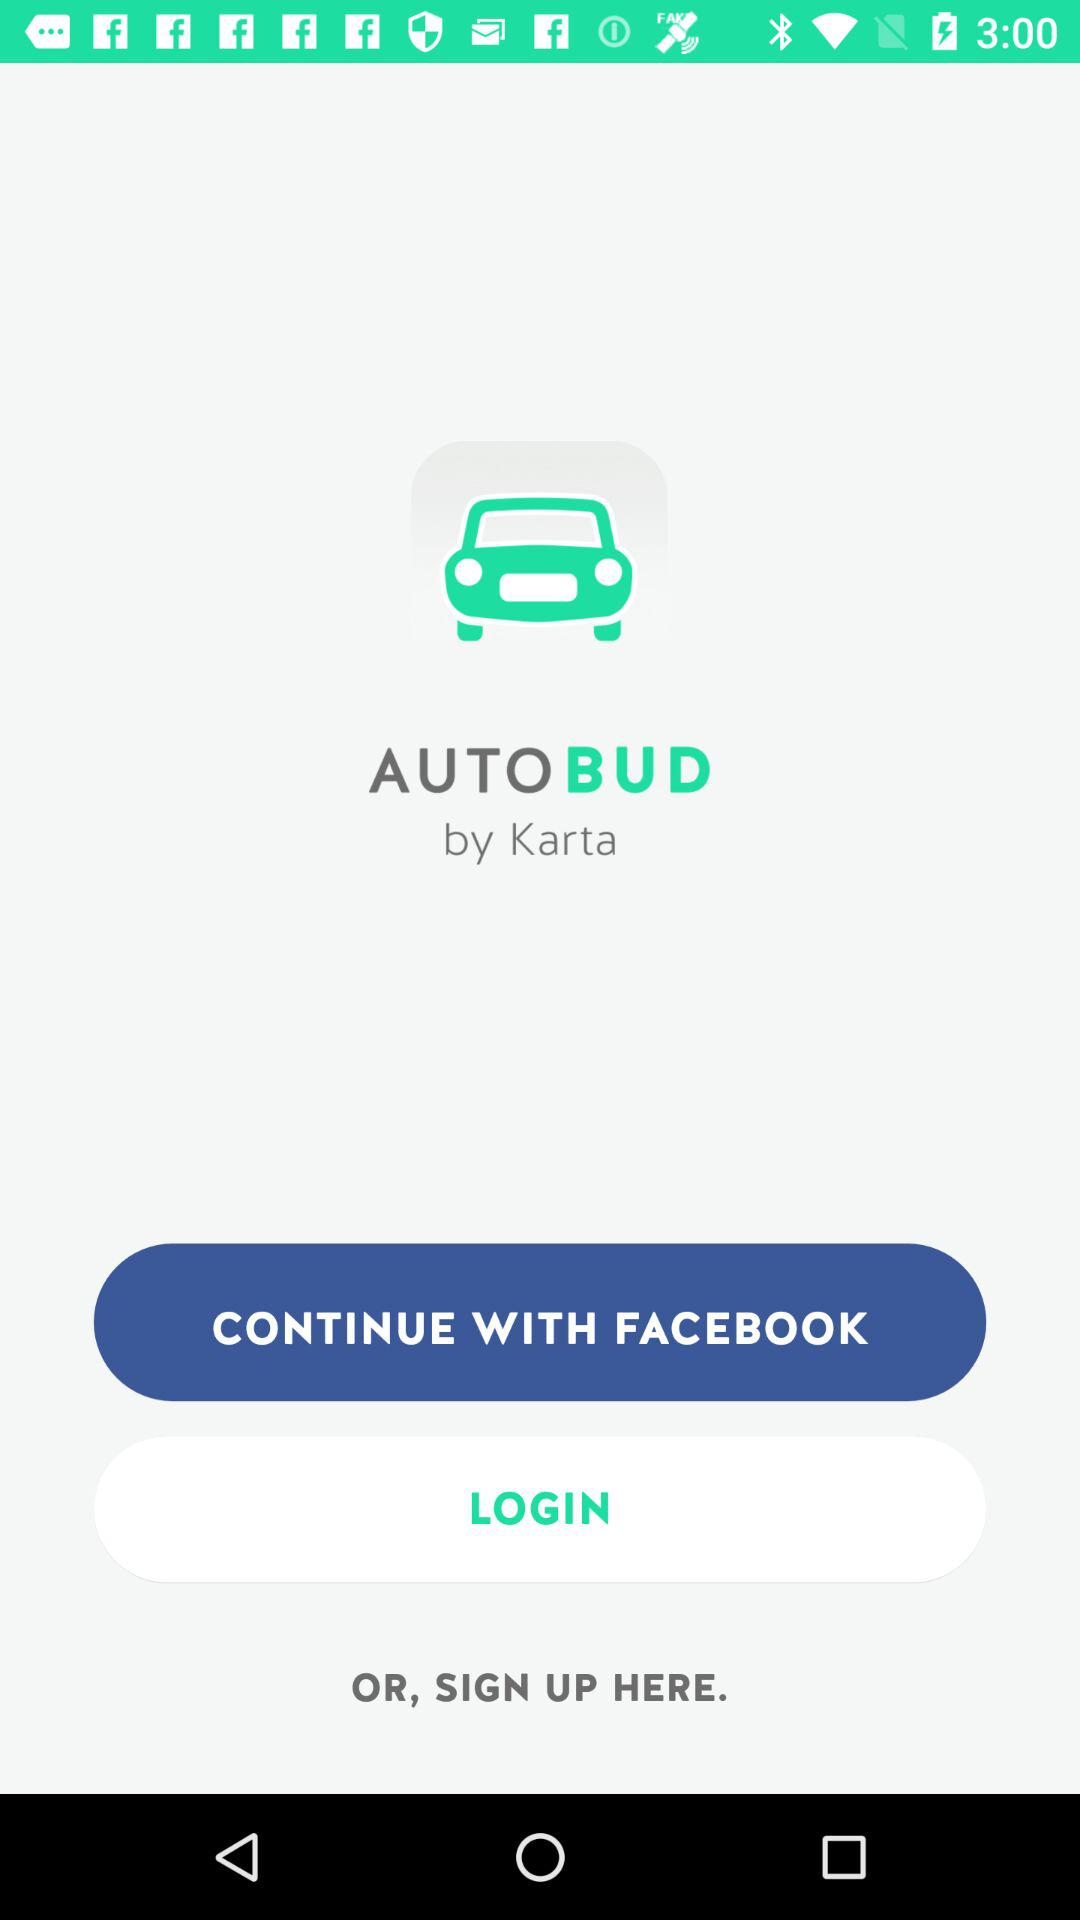What application is used to login? The application is Facebook. 